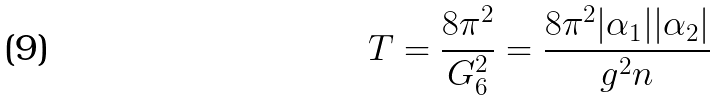Convert formula to latex. <formula><loc_0><loc_0><loc_500><loc_500>T = \frac { 8 \pi ^ { 2 } } { G _ { 6 } ^ { 2 } } = \frac { 8 \pi ^ { 2 } | \alpha _ { 1 } | | \alpha _ { 2 } | } { g ^ { 2 } n }</formula> 